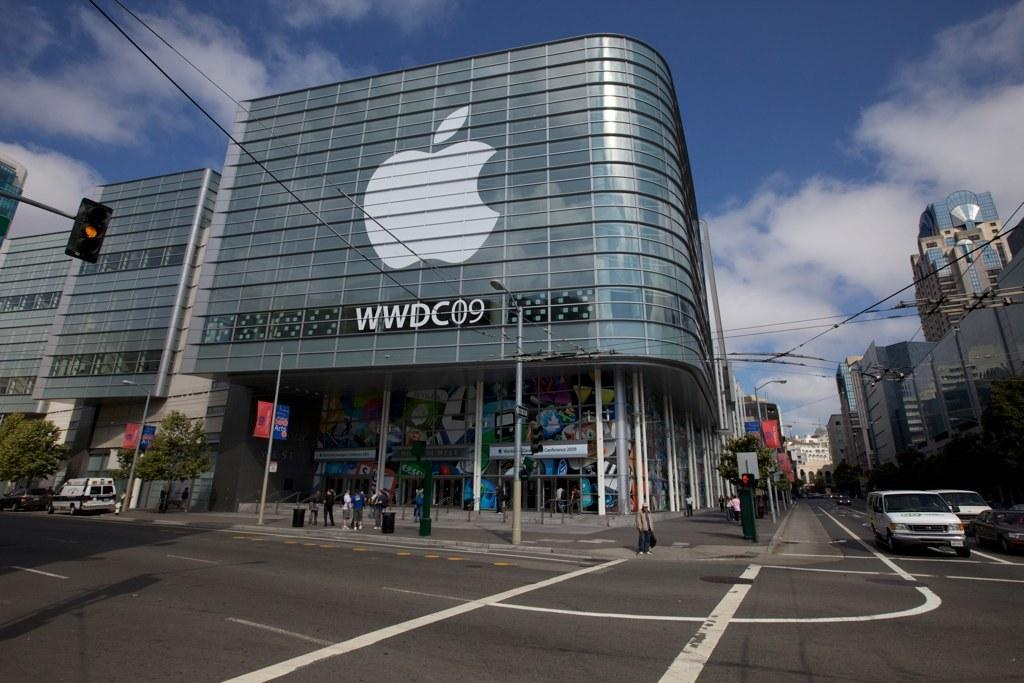What is in the foreground of the image? There is a road in the foreground of the image. Can you describe the people in the image? There are people in the image, but their specific actions or characteristics are not mentioned in the facts. What else can be seen in the image besides the road and people? There are vehicles, trees, poles, buildings, wires, and the sky visible in the image. What type of watch can be seen on the wrist of the person in the image? There is no mention of a watch or any specific clothing or accessories in the image. --- Facts: 1. There is a person sitting on a chair in the image. 2. The person is holding a book. 3. The book has a blue cover. 4. There is a table next to the chair. 5. There is a lamp on the table. 6. The background of the image is dark. Absurd Topics: elephant, ocean, mountain Conversation: What is the person in the image doing? The person is sitting on a chair in the image. What is the person holding in the image? The person is holding a book in the image. Can you describe the book? The book has a blue cover. What is located next to the chair in the image? There is a table next to the chair in the image. What is on the table in the image? There is a lamp on the table in the image. Reasoning: Let's think step by step in order to produce the conversation. We start by identifying the main subject in the image, which is the person sitting on a chair. Then, we mention the presence of a book and describe its cover color. Next, we acknowledge the presence of a table next to the chair and describe the object on the table, which is a lamp. Finally, we mention the background of the image, which is dark. Absurd Question/Answer: Can you see any elephants swimming in the ocean in the background of the image? There is no mention of an ocean or any animals in the image. 